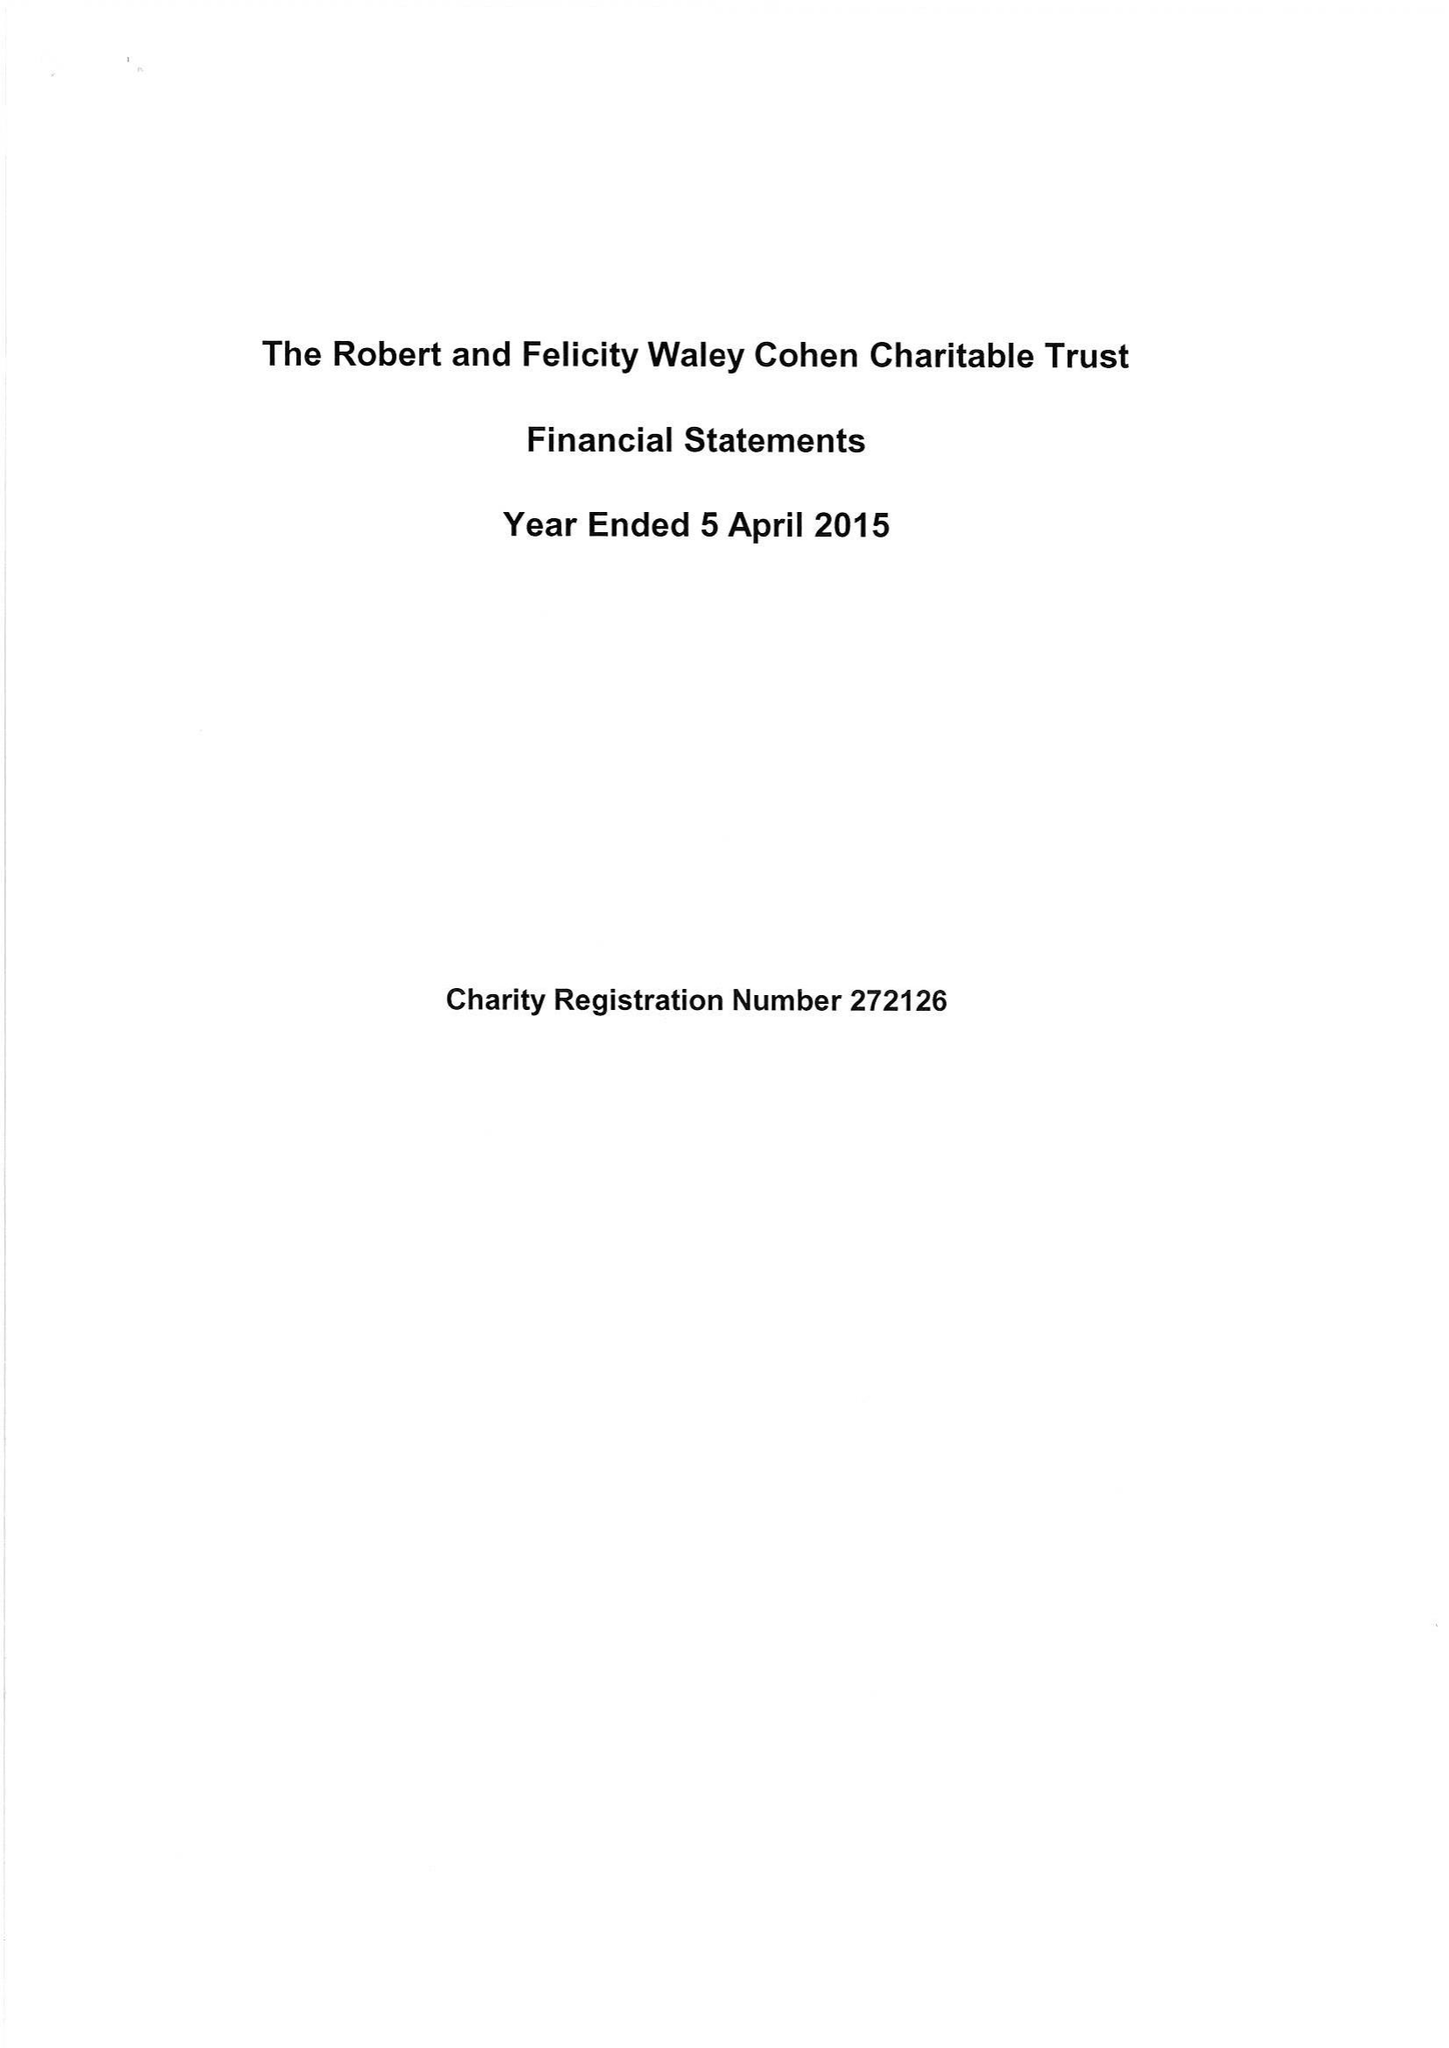What is the value for the address__post_town?
Answer the question using a single word or phrase. LONDON 